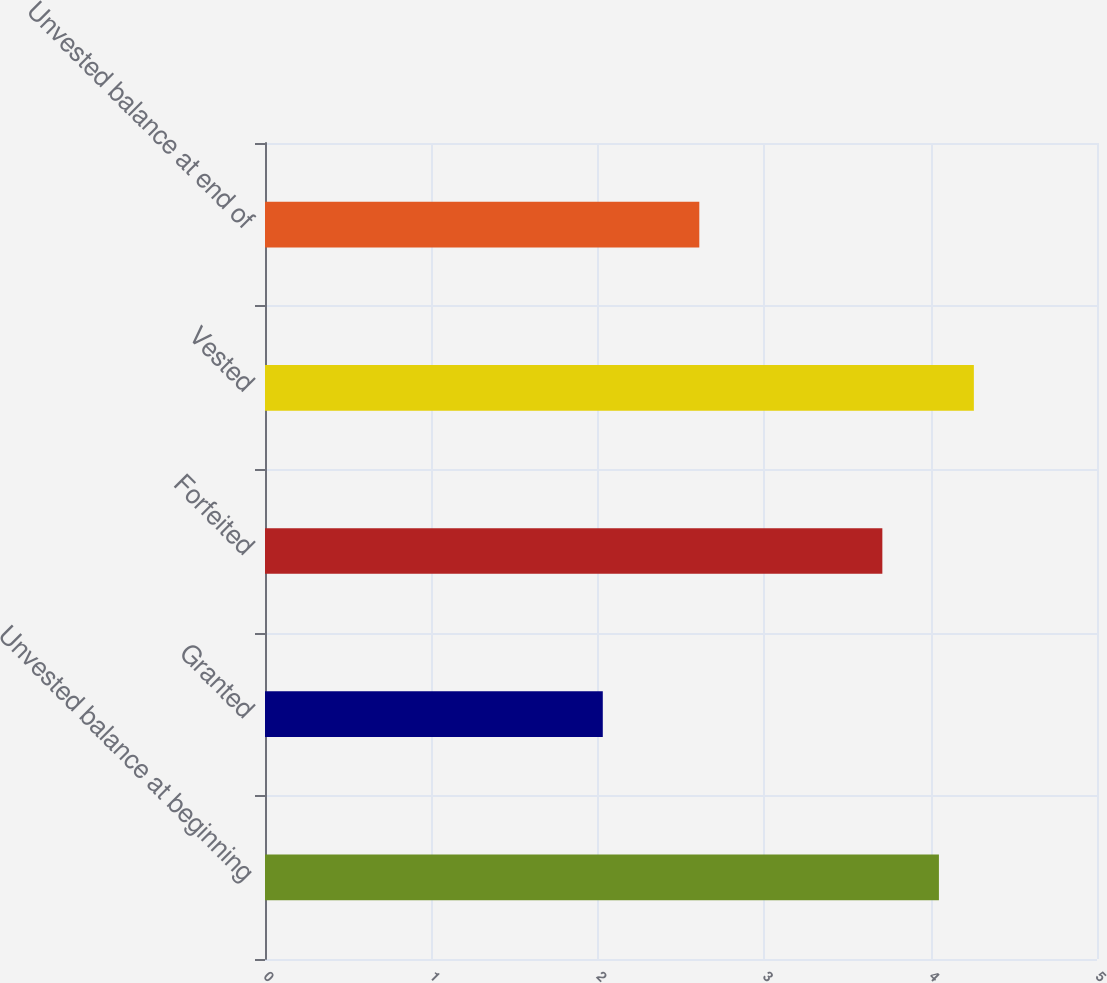Convert chart to OTSL. <chart><loc_0><loc_0><loc_500><loc_500><bar_chart><fcel>Unvested balance at beginning<fcel>Granted<fcel>Forfeited<fcel>Vested<fcel>Unvested balance at end of<nl><fcel>4.05<fcel>2.03<fcel>3.71<fcel>4.26<fcel>2.61<nl></chart> 